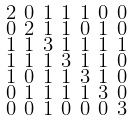Convert formula to latex. <formula><loc_0><loc_0><loc_500><loc_500>\begin{smallmatrix} 2 & 0 & 1 & 1 & 1 & 0 & 0 \\ 0 & 2 & 1 & 1 & 0 & 1 & 0 \\ 1 & 1 & 3 & 1 & 1 & 1 & 1 \\ 1 & 1 & 1 & 3 & 1 & 1 & 0 \\ 1 & 0 & 1 & 1 & 3 & 1 & 0 \\ 0 & 1 & 1 & 1 & 1 & 3 & 0 \\ 0 & 0 & 1 & 0 & 0 & 0 & 3 \end{smallmatrix}</formula> 